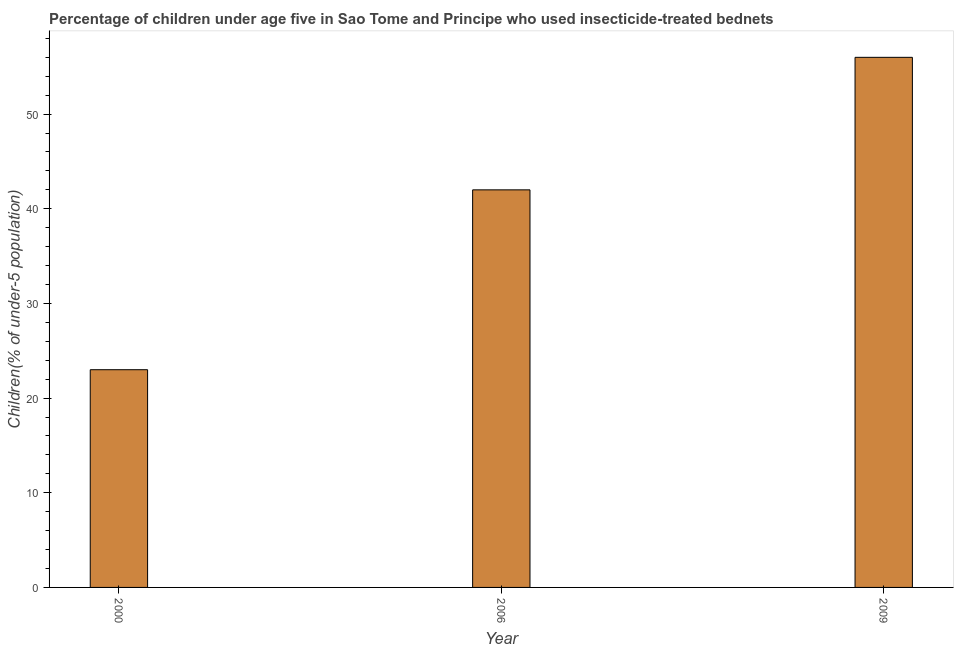Does the graph contain grids?
Offer a terse response. No. What is the title of the graph?
Make the answer very short. Percentage of children under age five in Sao Tome and Principe who used insecticide-treated bednets. What is the label or title of the Y-axis?
Make the answer very short. Children(% of under-5 population). What is the percentage of children who use of insecticide-treated bed nets in 2000?
Offer a very short reply. 23. Across all years, what is the maximum percentage of children who use of insecticide-treated bed nets?
Make the answer very short. 56. Across all years, what is the minimum percentage of children who use of insecticide-treated bed nets?
Your answer should be very brief. 23. In which year was the percentage of children who use of insecticide-treated bed nets maximum?
Your answer should be compact. 2009. What is the sum of the percentage of children who use of insecticide-treated bed nets?
Make the answer very short. 121. What is the difference between the percentage of children who use of insecticide-treated bed nets in 2000 and 2009?
Provide a short and direct response. -33. What is the median percentage of children who use of insecticide-treated bed nets?
Make the answer very short. 42. Do a majority of the years between 2000 and 2006 (inclusive) have percentage of children who use of insecticide-treated bed nets greater than 16 %?
Offer a terse response. Yes. What is the ratio of the percentage of children who use of insecticide-treated bed nets in 2000 to that in 2009?
Your answer should be very brief. 0.41. Is the percentage of children who use of insecticide-treated bed nets in 2000 less than that in 2006?
Offer a very short reply. Yes. Is the sum of the percentage of children who use of insecticide-treated bed nets in 2000 and 2009 greater than the maximum percentage of children who use of insecticide-treated bed nets across all years?
Offer a terse response. Yes. How many bars are there?
Provide a succinct answer. 3. Are all the bars in the graph horizontal?
Your answer should be compact. No. Are the values on the major ticks of Y-axis written in scientific E-notation?
Your answer should be very brief. No. What is the Children(% of under-5 population) of 2000?
Offer a terse response. 23. What is the Children(% of under-5 population) of 2009?
Make the answer very short. 56. What is the difference between the Children(% of under-5 population) in 2000 and 2009?
Your response must be concise. -33. What is the ratio of the Children(% of under-5 population) in 2000 to that in 2006?
Offer a very short reply. 0.55. What is the ratio of the Children(% of under-5 population) in 2000 to that in 2009?
Ensure brevity in your answer.  0.41. 